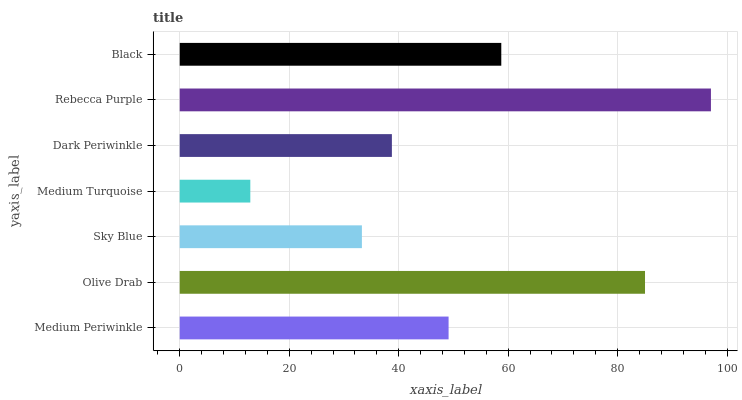Is Medium Turquoise the minimum?
Answer yes or no. Yes. Is Rebecca Purple the maximum?
Answer yes or no. Yes. Is Olive Drab the minimum?
Answer yes or no. No. Is Olive Drab the maximum?
Answer yes or no. No. Is Olive Drab greater than Medium Periwinkle?
Answer yes or no. Yes. Is Medium Periwinkle less than Olive Drab?
Answer yes or no. Yes. Is Medium Periwinkle greater than Olive Drab?
Answer yes or no. No. Is Olive Drab less than Medium Periwinkle?
Answer yes or no. No. Is Medium Periwinkle the high median?
Answer yes or no. Yes. Is Medium Periwinkle the low median?
Answer yes or no. Yes. Is Dark Periwinkle the high median?
Answer yes or no. No. Is Dark Periwinkle the low median?
Answer yes or no. No. 